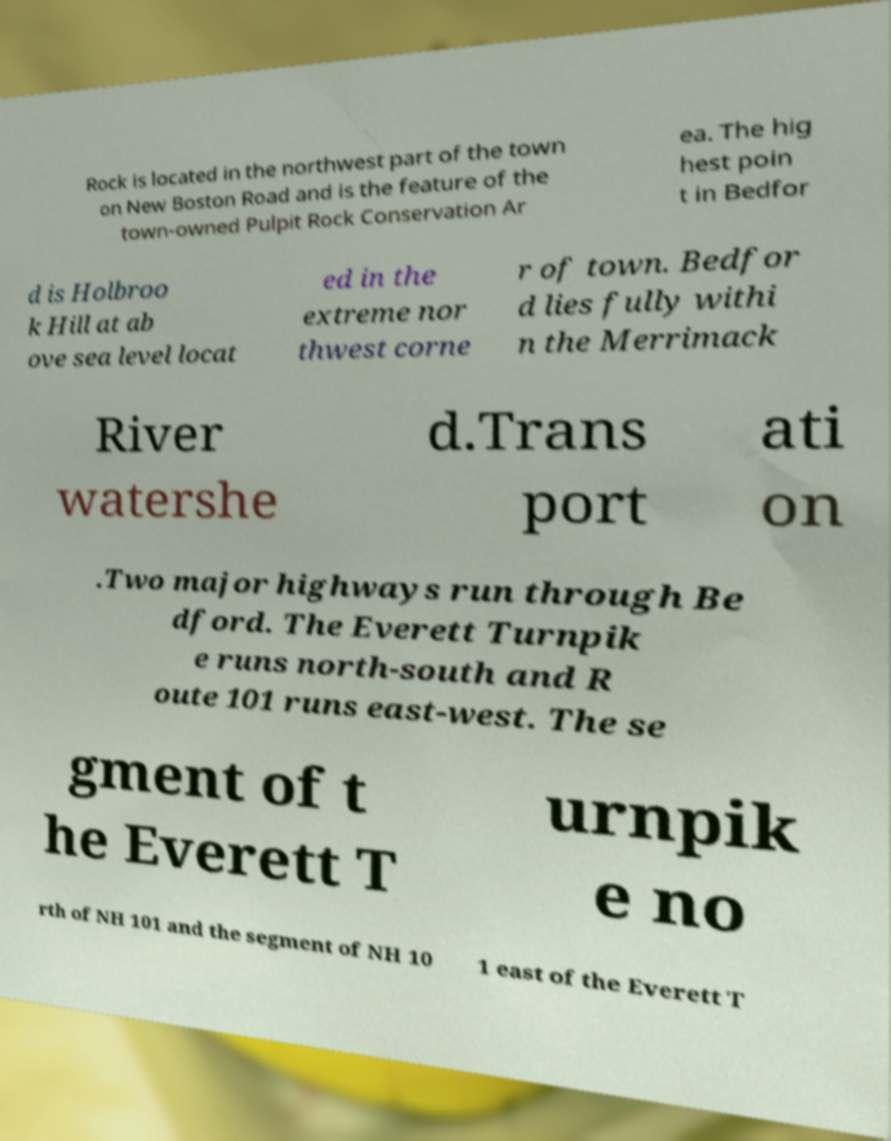Could you assist in decoding the text presented in this image and type it out clearly? Rock is located in the northwest part of the town on New Boston Road and is the feature of the town-owned Pulpit Rock Conservation Ar ea. The hig hest poin t in Bedfor d is Holbroo k Hill at ab ove sea level locat ed in the extreme nor thwest corne r of town. Bedfor d lies fully withi n the Merrimack River watershe d.Trans port ati on .Two major highways run through Be dford. The Everett Turnpik e runs north-south and R oute 101 runs east-west. The se gment of t he Everett T urnpik e no rth of NH 101 and the segment of NH 10 1 east of the Everett T 